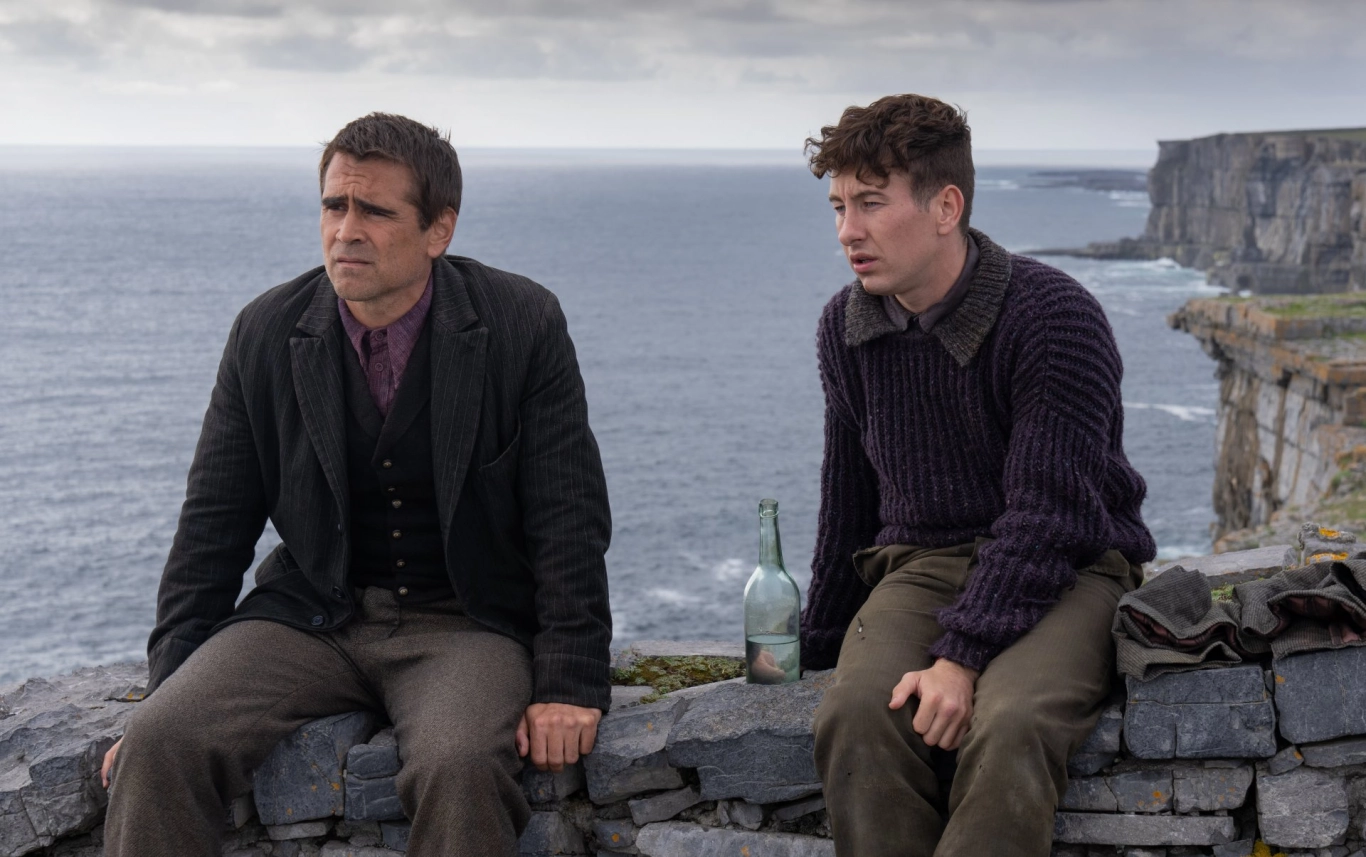What are the key elements in this picture? This image captures a contemplative moment between two individuals sitting on a stone wall overlooking the ocean. On the left, a man dressed in a dark suit and tie gazes towards the horizon, while his companion on the right wears a purple sweater and looks equally pensive. Between them on the stone wall are a green bottle and a backpack, hinting that they might be travelers taking a break. The backdrop of the expansive ocean and the rugged cliffs adds a dramatic and serene touch to the scene, highlighting the intensity and quietude of the moment. 